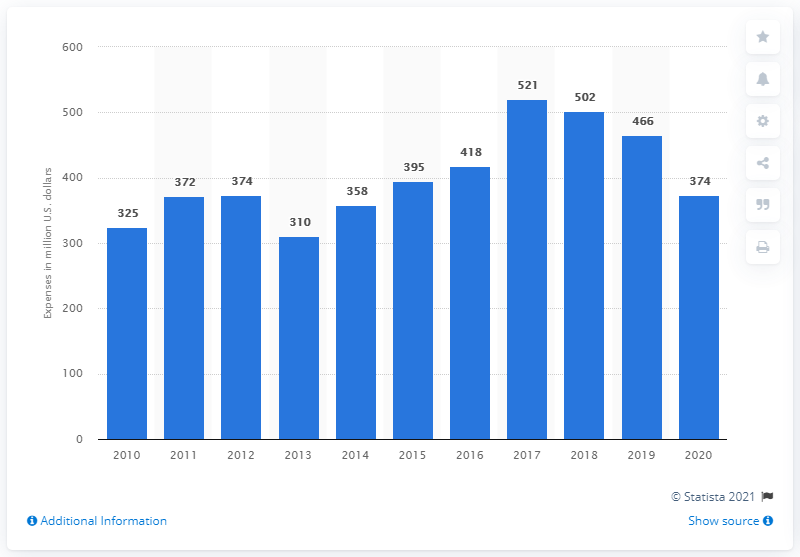Which year saw the highest R&D expenditure, and what was the amount? According to the graph, the year with the highest R&D expenditure by General Dynamics Corporation was 2019, with the amount reaching approximately $521 million. 